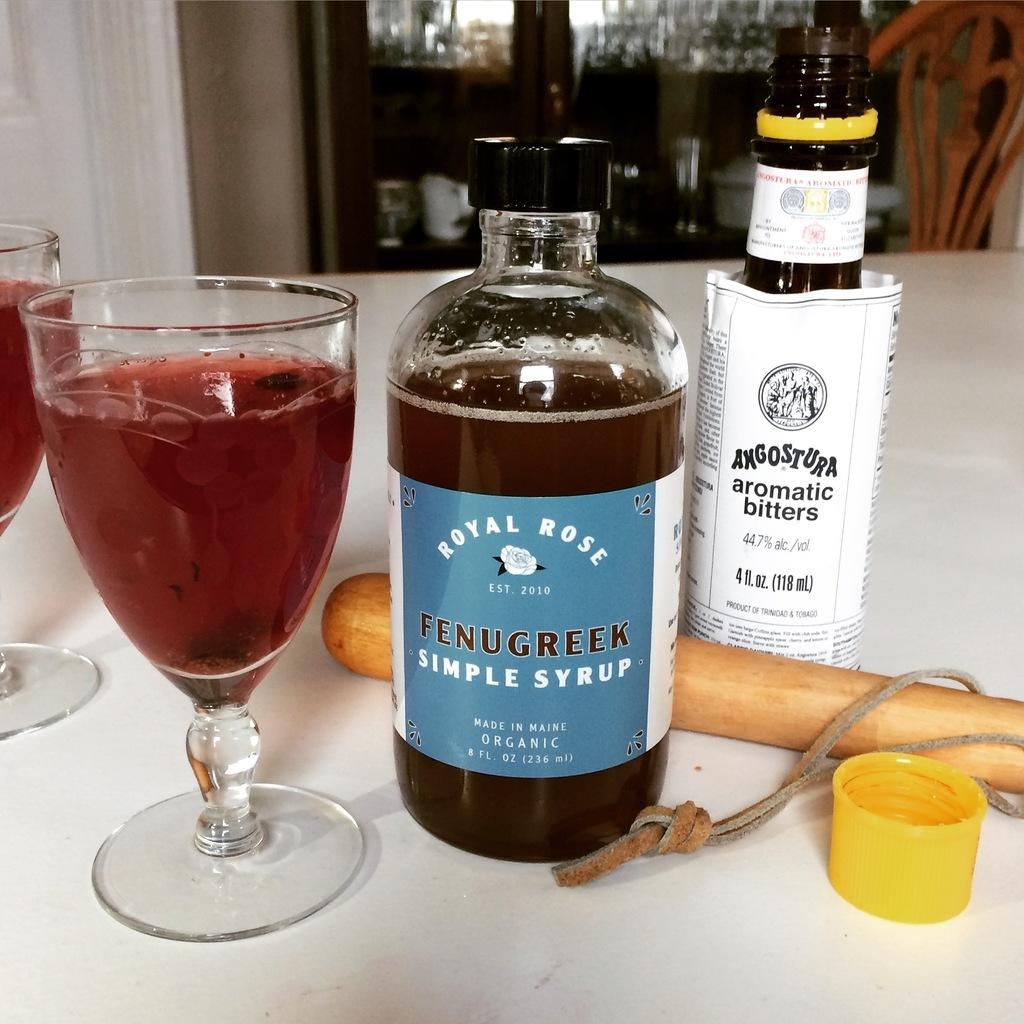Provide a one-sentence caption for the provided image. A mixed drink made from Fenugreek simple syrup and Angostura aromatic bitters. 